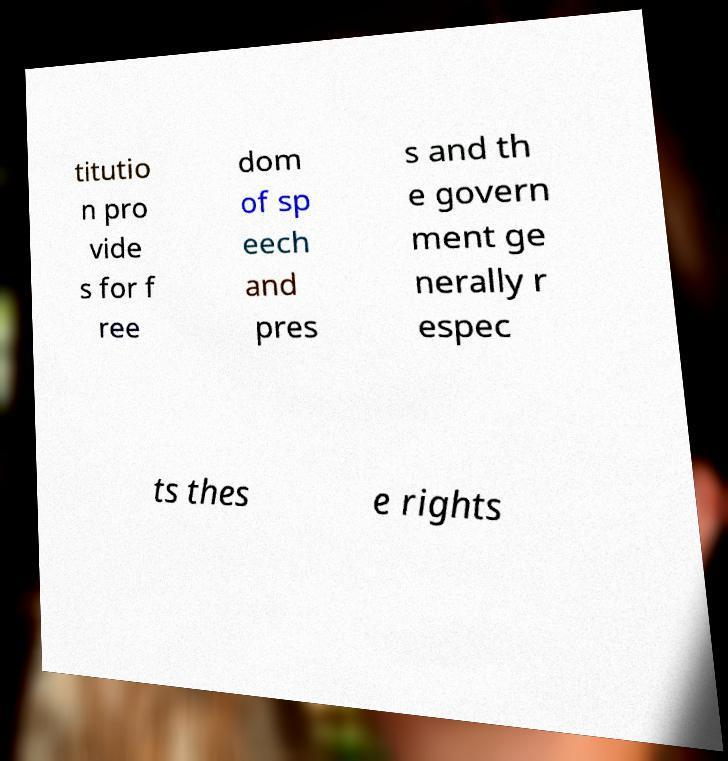There's text embedded in this image that I need extracted. Can you transcribe it verbatim? titutio n pro vide s for f ree dom of sp eech and pres s and th e govern ment ge nerally r espec ts thes e rights 